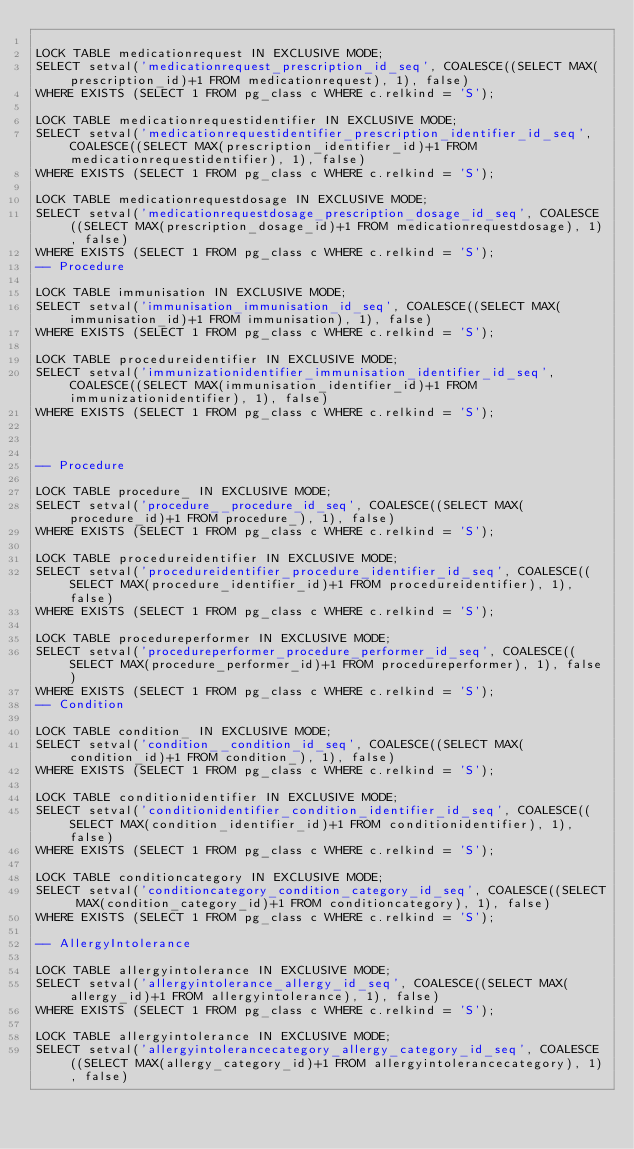<code> <loc_0><loc_0><loc_500><loc_500><_SQL_>
LOCK TABLE medicationrequest IN EXCLUSIVE MODE;
SELECT setval('medicationrequest_prescription_id_seq', COALESCE((SELECT MAX(prescription_id)+1 FROM medicationrequest), 1), false)
WHERE EXISTS (SELECT 1 FROM pg_class c WHERE c.relkind = 'S');

LOCK TABLE medicationrequestidentifier IN EXCLUSIVE MODE;
SELECT setval('medicationrequestidentifier_prescription_identifier_id_seq', COALESCE((SELECT MAX(prescription_identifier_id)+1 FROM medicationrequestidentifier), 1), false)
WHERE EXISTS (SELECT 1 FROM pg_class c WHERE c.relkind = 'S');

LOCK TABLE medicationrequestdosage IN EXCLUSIVE MODE;
SELECT setval('medicationrequestdosage_prescription_dosage_id_seq', COALESCE((SELECT MAX(prescription_dosage_id)+1 FROM medicationrequestdosage), 1), false)
WHERE EXISTS (SELECT 1 FROM pg_class c WHERE c.relkind = 'S');
-- Procedure 

LOCK TABLE immunisation IN EXCLUSIVE MODE;
SELECT setval('immunisation_immunisation_id_seq', COALESCE((SELECT MAX(immunisation_id)+1 FROM immunisation), 1), false)
WHERE EXISTS (SELECT 1 FROM pg_class c WHERE c.relkind = 'S');

LOCK TABLE procedureidentifier IN EXCLUSIVE MODE;
SELECT setval('immunizationidentifier_immunisation_identifier_id_seq', COALESCE((SELECT MAX(immunisation_identifier_id)+1 FROM immunizationidentifier), 1), false)
WHERE EXISTS (SELECT 1 FROM pg_class c WHERE c.relkind = 'S');



-- Procedure 

LOCK TABLE procedure_ IN EXCLUSIVE MODE;
SELECT setval('procedure__procedure_id_seq', COALESCE((SELECT MAX(procedure_id)+1 FROM procedure_), 1), false)
WHERE EXISTS (SELECT 1 FROM pg_class c WHERE c.relkind = 'S');

LOCK TABLE procedureidentifier IN EXCLUSIVE MODE;
SELECT setval('procedureidentifier_procedure_identifier_id_seq', COALESCE((SELECT MAX(procedure_identifier_id)+1 FROM procedureidentifier), 1), false)
WHERE EXISTS (SELECT 1 FROM pg_class c WHERE c.relkind = 'S');

LOCK TABLE procedureperformer IN EXCLUSIVE MODE;
SELECT setval('procedureperformer_procedure_performer_id_seq', COALESCE((SELECT MAX(procedure_performer_id)+1 FROM procedureperformer), 1), false)
WHERE EXISTS (SELECT 1 FROM pg_class c WHERE c.relkind = 'S');
-- Condition 

LOCK TABLE condition_ IN EXCLUSIVE MODE;
SELECT setval('condition__condition_id_seq', COALESCE((SELECT MAX(condition_id)+1 FROM condition_), 1), false)
WHERE EXISTS (SELECT 1 FROM pg_class c WHERE c.relkind = 'S');

LOCK TABLE conditionidentifier IN EXCLUSIVE MODE;
SELECT setval('conditionidentifier_condition_identifier_id_seq', COALESCE((SELECT MAX(condition_identifier_id)+1 FROM conditionidentifier), 1), false)
WHERE EXISTS (SELECT 1 FROM pg_class c WHERE c.relkind = 'S');

LOCK TABLE conditioncategory IN EXCLUSIVE MODE;
SELECT setval('conditioncategory_condition_category_id_seq', COALESCE((SELECT MAX(condition_category_id)+1 FROM conditioncategory), 1), false)
WHERE EXISTS (SELECT 1 FROM pg_class c WHERE c.relkind = 'S');

-- AllergyIntolerance 

LOCK TABLE allergyintolerance IN EXCLUSIVE MODE;
SELECT setval('allergyintolerance_allergy_id_seq', COALESCE((SELECT MAX(allergy_id)+1 FROM allergyintolerance), 1), false)
WHERE EXISTS (SELECT 1 FROM pg_class c WHERE c.relkind = 'S');

LOCK TABLE allergyintolerance IN EXCLUSIVE MODE;
SELECT setval('allergyintolerancecategory_allergy_category_id_seq', COALESCE((SELECT MAX(allergy_category_id)+1 FROM allergyintolerancecategory), 1), false)</code> 